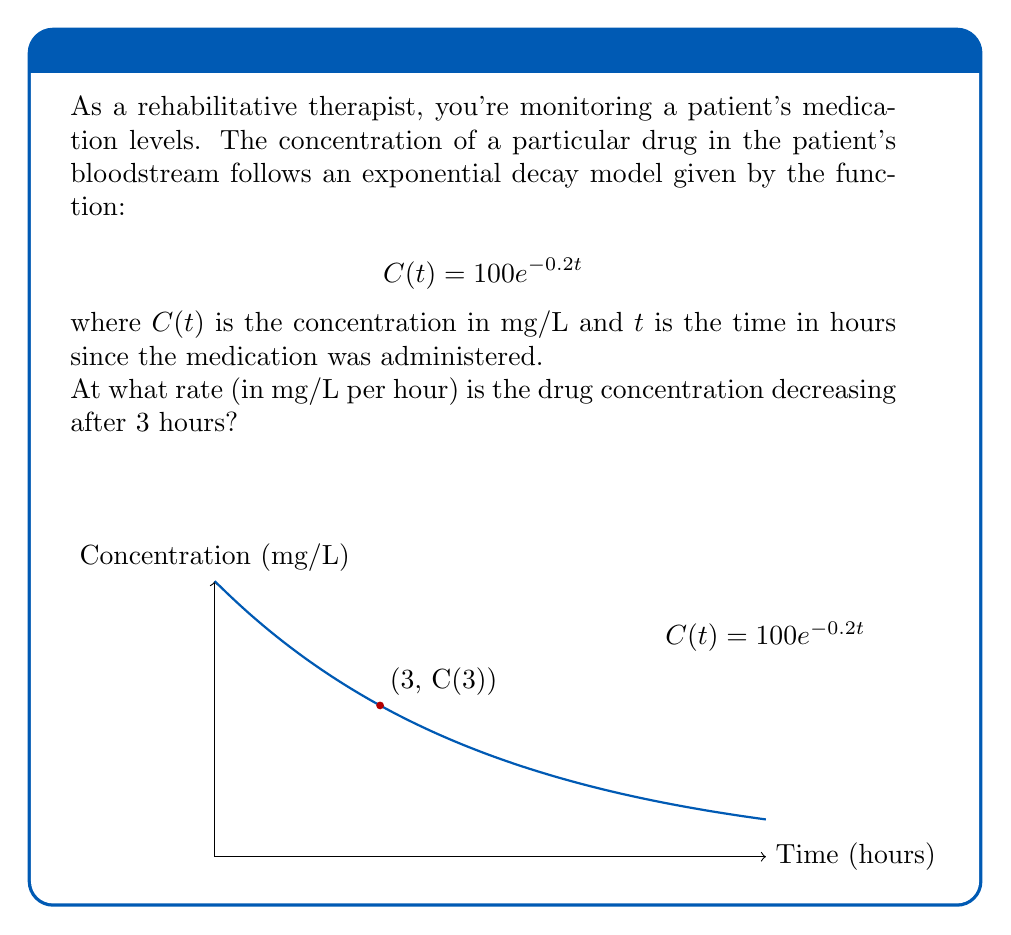Can you solve this math problem? To solve this problem, we need to find the rate of change of the concentration at $t = 3$ hours. This is equivalent to finding the derivative of $C(t)$ at $t = 3$.

Step 1: Find the derivative of $C(t)$.
$$\frac{d}{dt}C(t) = \frac{d}{dt}(100e^{-0.2t}) = 100 \cdot (-0.2)e^{-0.2t} = -20e^{-0.2t}$$

Step 2: Evaluate the derivative at $t = 3$.
$$\left.\frac{d}{dt}C(t)\right|_{t=3} = -20e^{-0.2(3)} = -20e^{-0.6}$$

Step 3: Calculate the final value.
$$-20e^{-0.6} \approx -10.98 \text{ mg/L per hour}$$

The negative sign indicates that the concentration is decreasing.
Answer: $-10.98 \text{ mg/L per hour}$ 